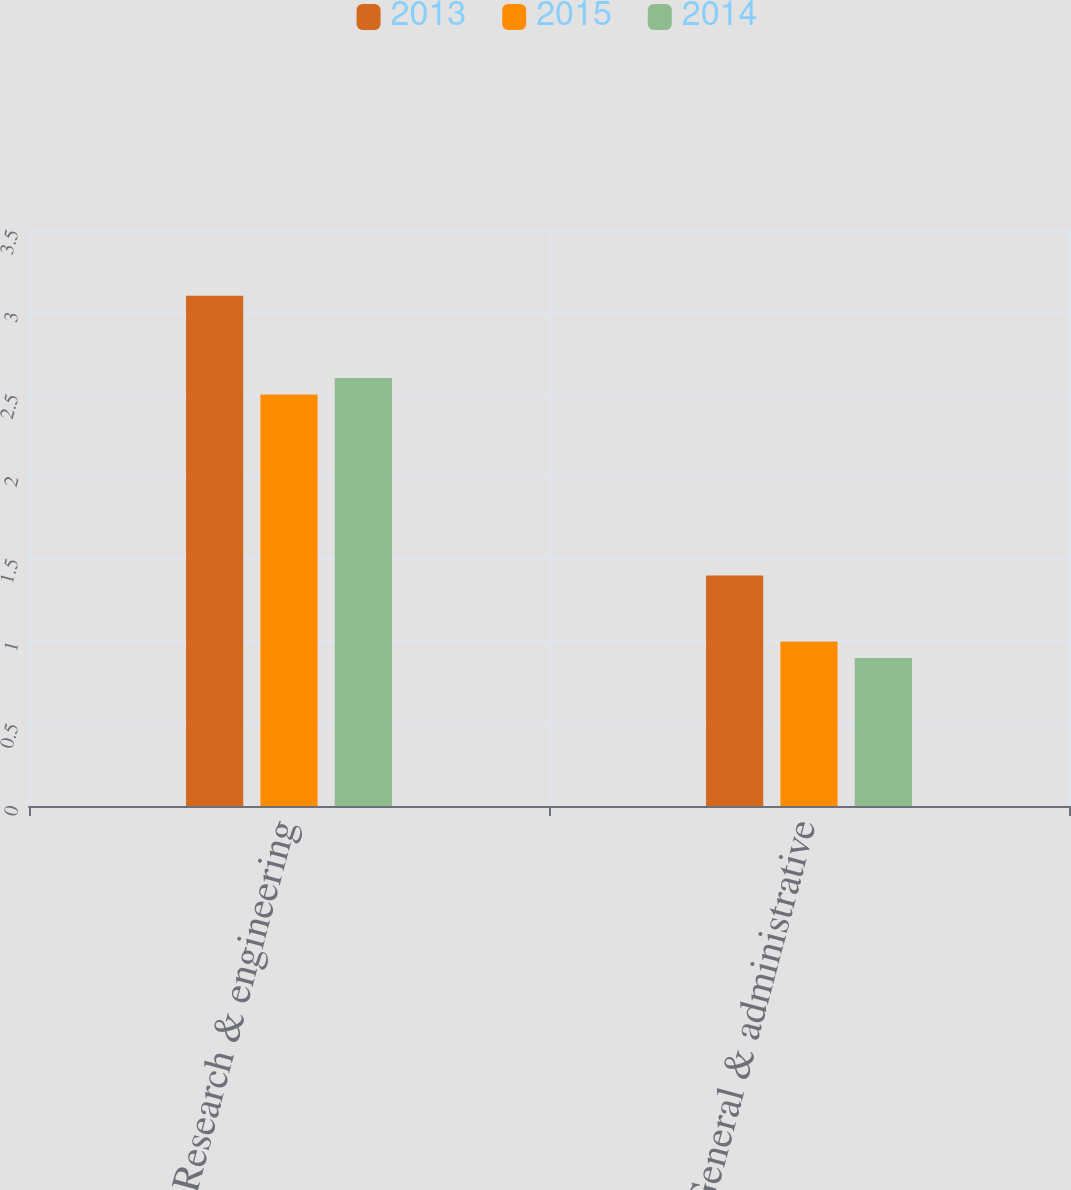Convert chart to OTSL. <chart><loc_0><loc_0><loc_500><loc_500><stacked_bar_chart><ecel><fcel>Research & engineering<fcel>General & administrative<nl><fcel>2013<fcel>3.1<fcel>1.4<nl><fcel>2015<fcel>2.5<fcel>1<nl><fcel>2014<fcel>2.6<fcel>0.9<nl></chart> 